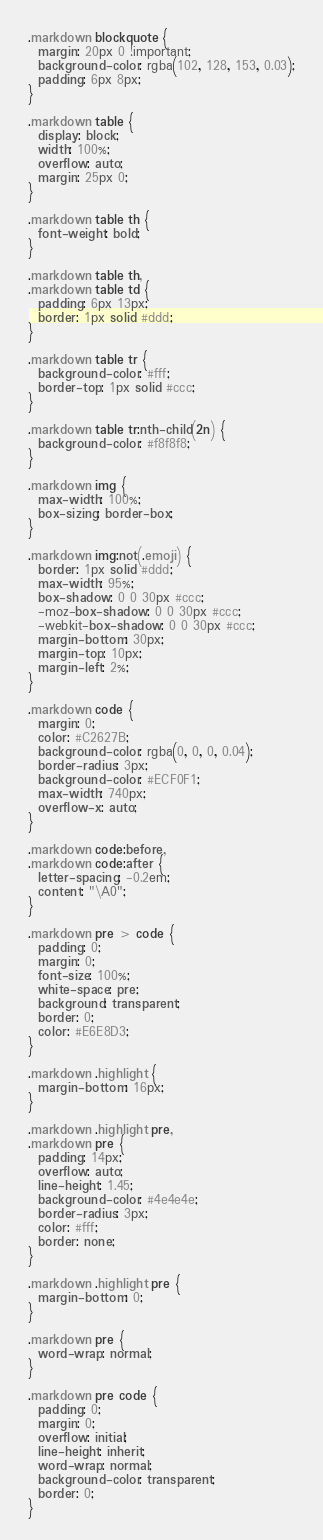Convert code to text. <code><loc_0><loc_0><loc_500><loc_500><_CSS_>
.markdown blockquote {
  margin: 20px 0 !important;
  background-color: rgba(102, 128, 153, 0.03);
  padding: 6px 8px;
}

.markdown table {
  display: block;
  width: 100%;
  overflow: auto;
  margin: 25px 0;
}

.markdown table th {
  font-weight: bold;
}

.markdown table th,
.markdown table td {
  padding: 6px 13px;
  border: 1px solid #ddd;
}

.markdown table tr {
  background-color: #fff;
  border-top: 1px solid #ccc;
}

.markdown table tr:nth-child(2n) {
  background-color: #f8f8f8;
}

.markdown img {
  max-width: 100%;
  box-sizing: border-box;
}

.markdown img:not(.emoji) {
  border: 1px solid #ddd;
  max-width: 95%;
  box-shadow: 0 0 30px #ccc;
  -moz-box-shadow: 0 0 30px #ccc;
  -webkit-box-shadow: 0 0 30px #ccc;
  margin-bottom: 30px;
  margin-top: 10px;
  margin-left: 2%;
}

.markdown code {
  margin: 0;
  color: #C2627B;
  background-color: rgba(0, 0, 0, 0.04);
  border-radius: 3px;
  background-color: #ECF0F1;
  max-width: 740px;
  overflow-x: auto;
}

.markdown code:before,
.markdown code:after {
  letter-spacing: -0.2em;
  content: "\A0";
}

.markdown pre > code {
  padding: 0;
  margin: 0;
  font-size: 100%;
  white-space: pre;
  background: transparent;
  border: 0;
  color: #E6E8D3;
}

.markdown .highlight {
  margin-bottom: 16px;
}

.markdown .highlight pre,
.markdown pre {
  padding: 14px;
  overflow: auto;
  line-height: 1.45;
  background-color: #4e4e4e;
  border-radius: 3px;
  color: #fff;
  border: none;
}

.markdown .highlight pre {
  margin-bottom: 0;
}

.markdown pre {
  word-wrap: normal;
}

.markdown pre code {
  padding: 0;
  margin: 0;
  overflow: initial;
  line-height: inherit;
  word-wrap: normal;
  background-color: transparent;
  border: 0;
}
</code> 